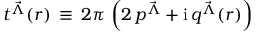<formula> <loc_0><loc_0><loc_500><loc_500>t ^ { { \vec { \Lambda } } } ( r ) \, \equiv \, 2 \pi \, \left ( 2 \, p ^ { { \vec { \Lambda } } } + i \, q ^ { { \vec { \Lambda } } } ( r ) \right )</formula> 